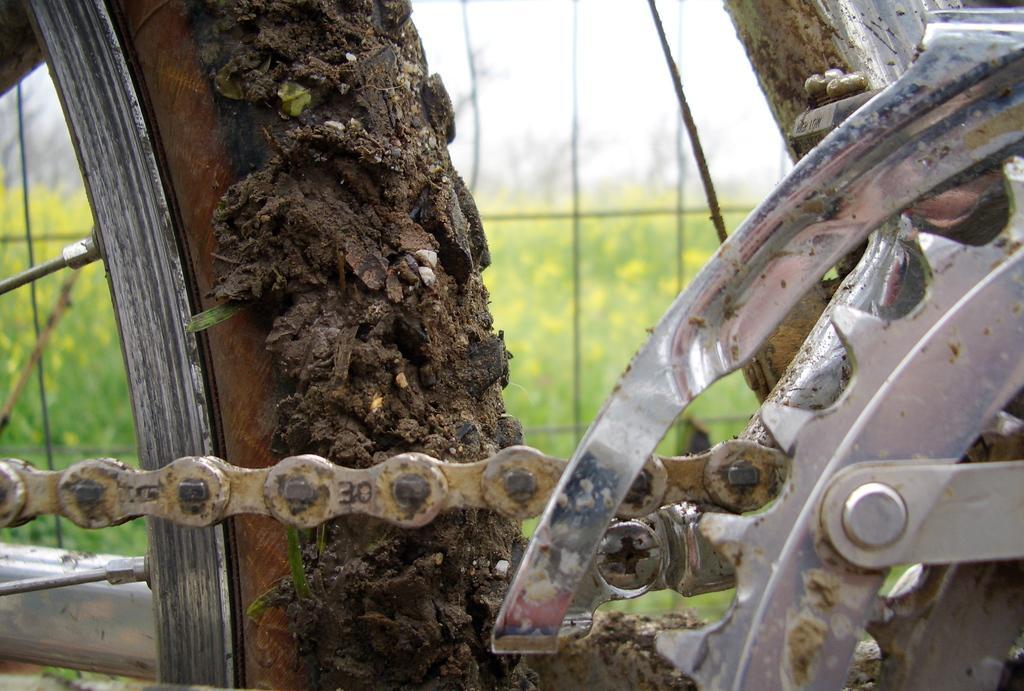Could you give a brief overview of what you see in this image? It's a zoomed in picture of a bicycle chain and a wheel. 